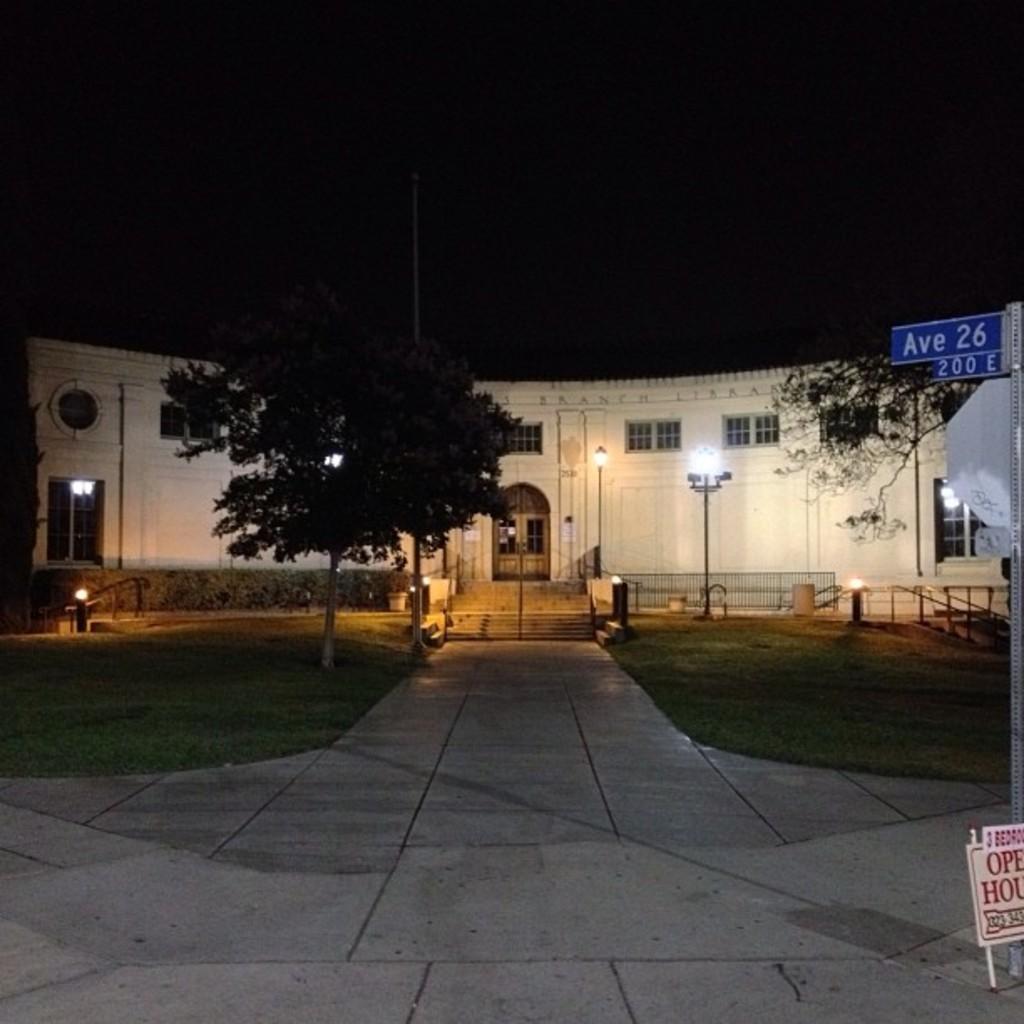Can you describe this image briefly? This picture is clicked outside. In the center we can see the green grass, lights attached to the poles and we can see the trees and we can see the boards on which we can see the text and we can see the buildings and the windows and doors of the buildings. In the background we can see the sky. 